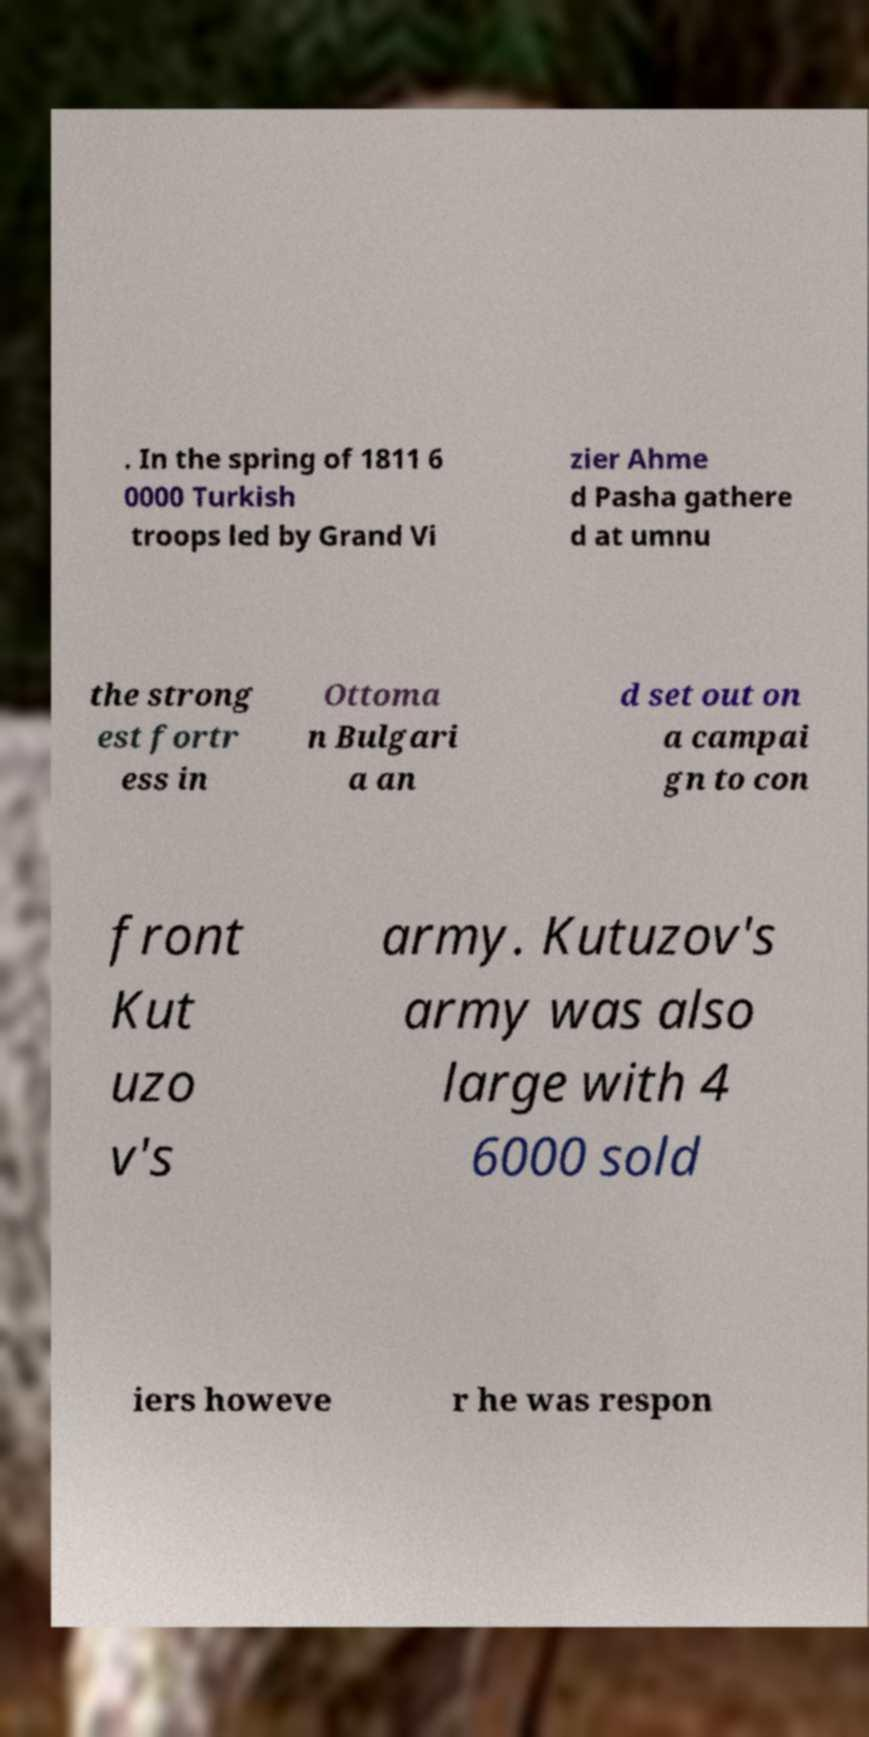Can you accurately transcribe the text from the provided image for me? . In the spring of 1811 6 0000 Turkish troops led by Grand Vi zier Ahme d Pasha gathere d at umnu the strong est fortr ess in Ottoma n Bulgari a an d set out on a campai gn to con front Kut uzo v's army. Kutuzov's army was also large with 4 6000 sold iers howeve r he was respon 